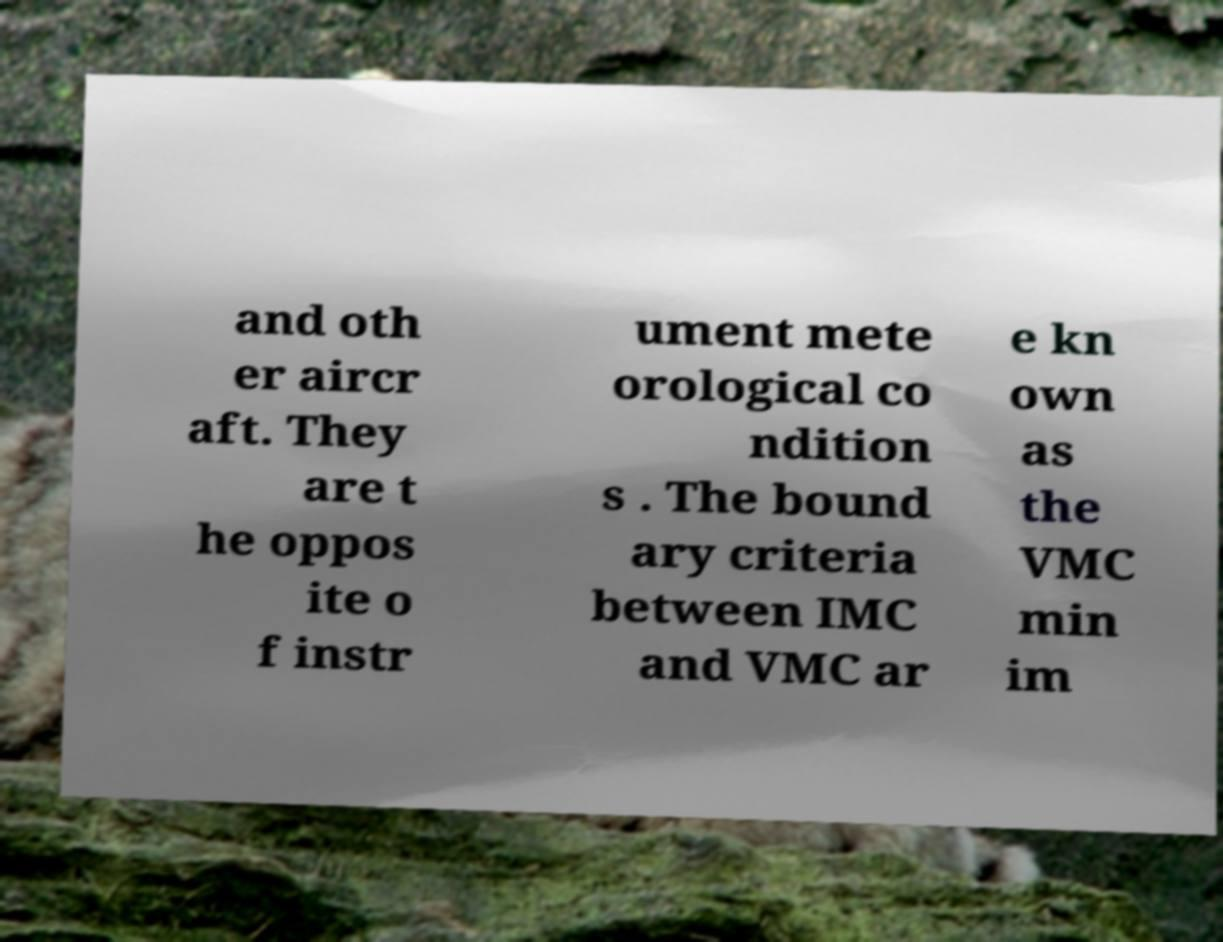For documentation purposes, I need the text within this image transcribed. Could you provide that? and oth er aircr aft. They are t he oppos ite o f instr ument mete orological co ndition s . The bound ary criteria between IMC and VMC ar e kn own as the VMC min im 